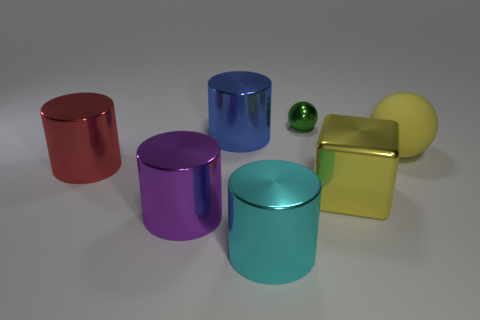Subtract all cyan shiny cylinders. How many cylinders are left? 3 Add 2 large yellow metal cubes. How many objects exist? 9 Subtract all yellow spheres. How many spheres are left? 1 Subtract all cylinders. How many objects are left? 3 Add 6 purple cylinders. How many purple cylinders are left? 7 Add 3 big matte spheres. How many big matte spheres exist? 4 Subtract 1 cyan cylinders. How many objects are left? 6 Subtract 2 cylinders. How many cylinders are left? 2 Subtract all blue cylinders. Subtract all cyan blocks. How many cylinders are left? 3 Subtract all gray cylinders. How many brown balls are left? 0 